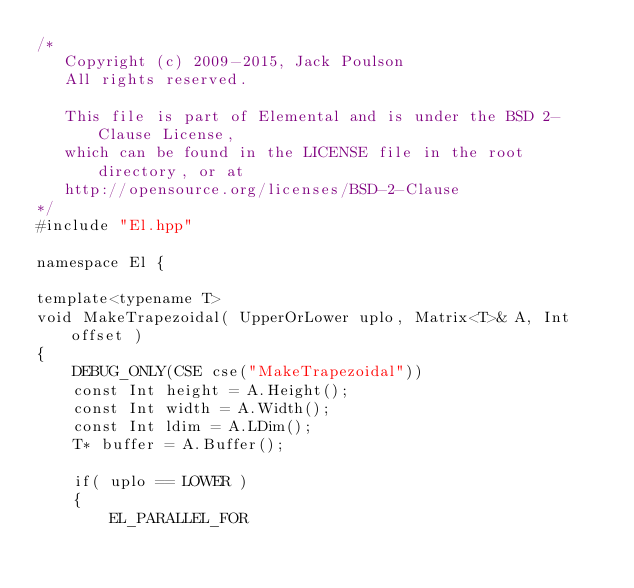Convert code to text. <code><loc_0><loc_0><loc_500><loc_500><_C++_>/*
   Copyright (c) 2009-2015, Jack Poulson
   All rights reserved.

   This file is part of Elemental and is under the BSD 2-Clause License, 
   which can be found in the LICENSE file in the root directory, or at 
   http://opensource.org/licenses/BSD-2-Clause
*/
#include "El.hpp"

namespace El {

template<typename T>
void MakeTrapezoidal( UpperOrLower uplo, Matrix<T>& A, Int offset )
{
    DEBUG_ONLY(CSE cse("MakeTrapezoidal"))
    const Int height = A.Height();
    const Int width = A.Width();
    const Int ldim = A.LDim();
    T* buffer = A.Buffer();

    if( uplo == LOWER )
    {
        EL_PARALLEL_FOR</code> 